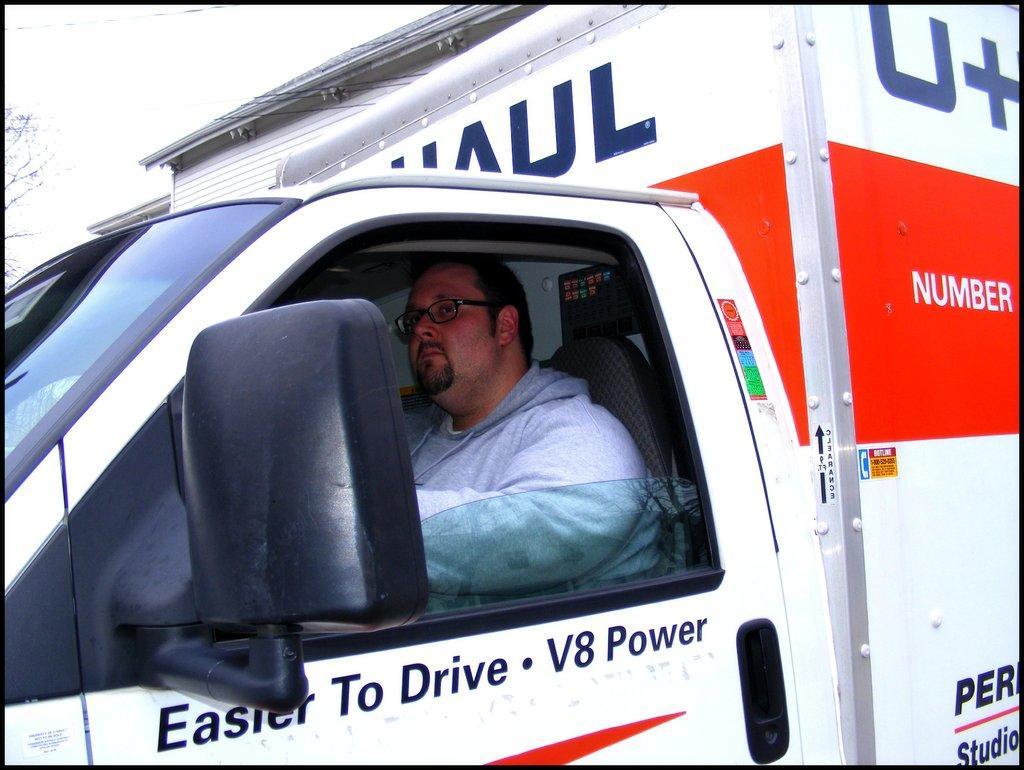How would you summarize this image in a sentence or two? In this picture we can see a vehicle in the front, there is a person sitting in the vehicle, on the left side we can see branches of a tree, at the right bottom there is some text. 